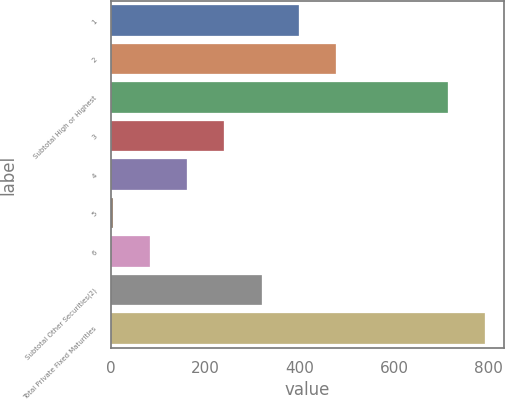Convert chart. <chart><loc_0><loc_0><loc_500><loc_500><bar_chart><fcel>1<fcel>2<fcel>Subtotal High or Highest<fcel>3<fcel>4<fcel>5<fcel>6<fcel>Subtotal Other Securities(2)<fcel>Total Private Fixed Maturities<nl><fcel>397<fcel>475.6<fcel>714<fcel>239.8<fcel>161.2<fcel>4<fcel>82.6<fcel>318.4<fcel>792.6<nl></chart> 